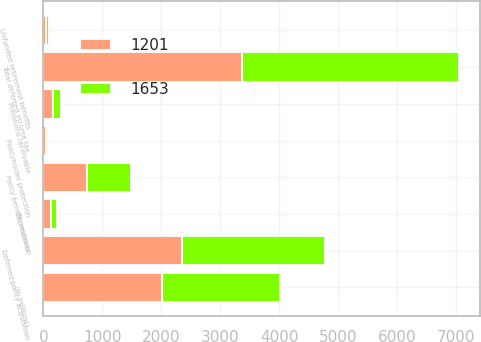Convert chart. <chart><loc_0><loc_0><loc_500><loc_500><stacked_bar_chart><ecel><fcel>(In millions)<fcel>Deferred policy acquisition<fcel>Premiums receivable<fcel>Policy benefit reserves<fcel>Total deferred income tax<fcel>Depreciation<fcel>Policyholder protection<fcel>Unfunded retirement benefits<nl><fcel>1653<fcel>2009<fcel>2422<fcel>149<fcel>751<fcel>3691<fcel>109<fcel>27<fcel>44<nl><fcel>1201<fcel>2008<fcel>2356<fcel>155<fcel>735<fcel>3358<fcel>128<fcel>48<fcel>44<nl></chart> 